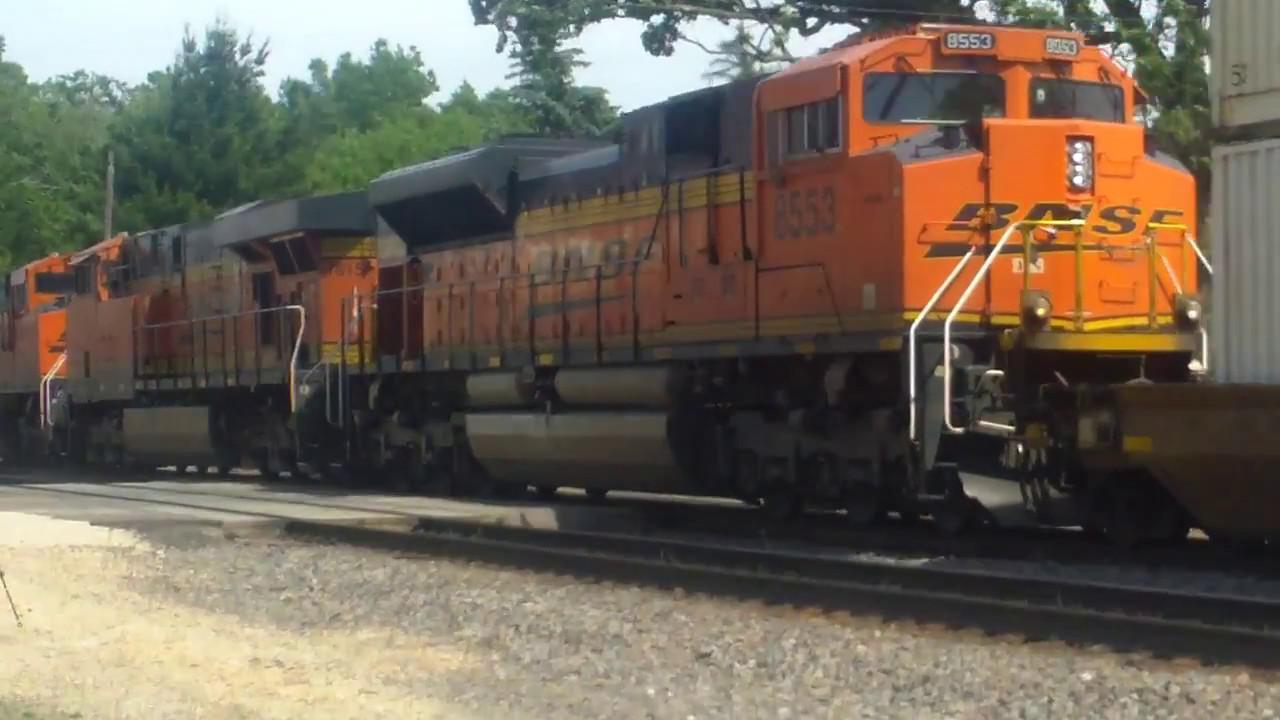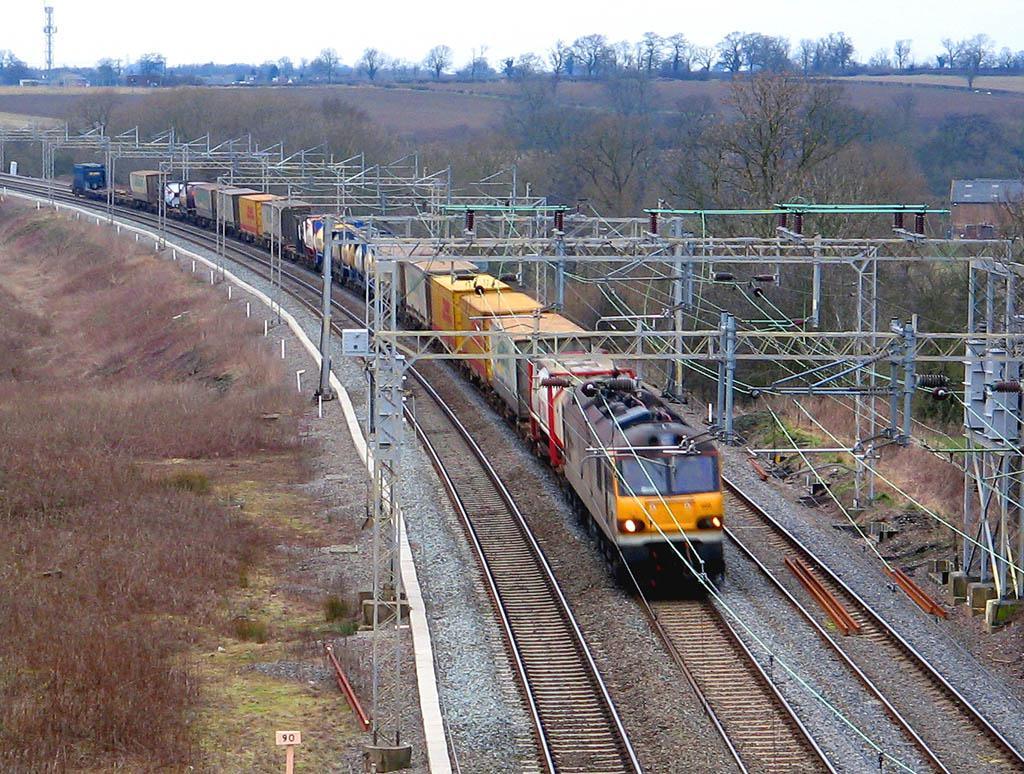The first image is the image on the left, the second image is the image on the right. Assess this claim about the two images: "Multiple tracks are visible in the left image.". Correct or not? Answer yes or no. No. The first image is the image on the left, the second image is the image on the right. Given the left and right images, does the statement "in at least one image a train has headlights on" hold true? Answer yes or no. Yes. 